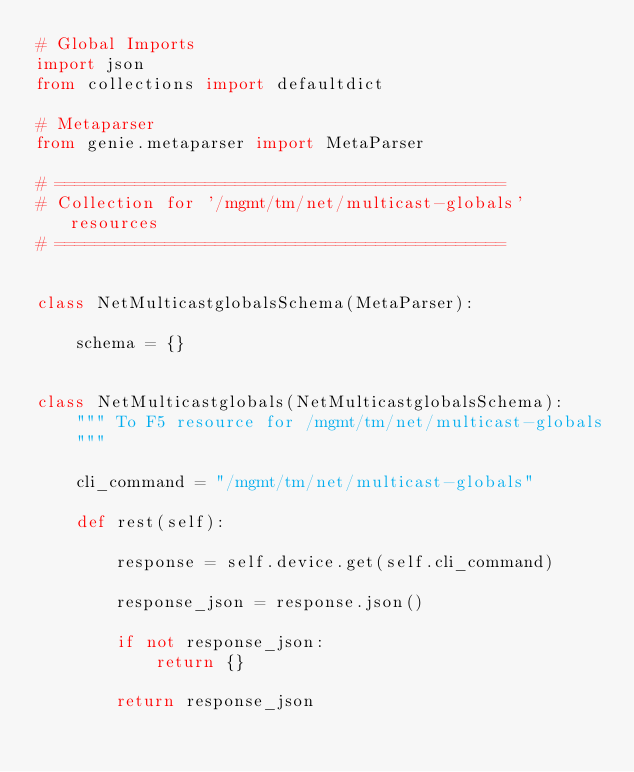<code> <loc_0><loc_0><loc_500><loc_500><_Python_># Global Imports
import json
from collections import defaultdict

# Metaparser
from genie.metaparser import MetaParser

# =============================================
# Collection for '/mgmt/tm/net/multicast-globals' resources
# =============================================


class NetMulticastglobalsSchema(MetaParser):

    schema = {}


class NetMulticastglobals(NetMulticastglobalsSchema):
    """ To F5 resource for /mgmt/tm/net/multicast-globals
    """

    cli_command = "/mgmt/tm/net/multicast-globals"

    def rest(self):

        response = self.device.get(self.cli_command)

        response_json = response.json()

        if not response_json:
            return {}

        return response_json
</code> 